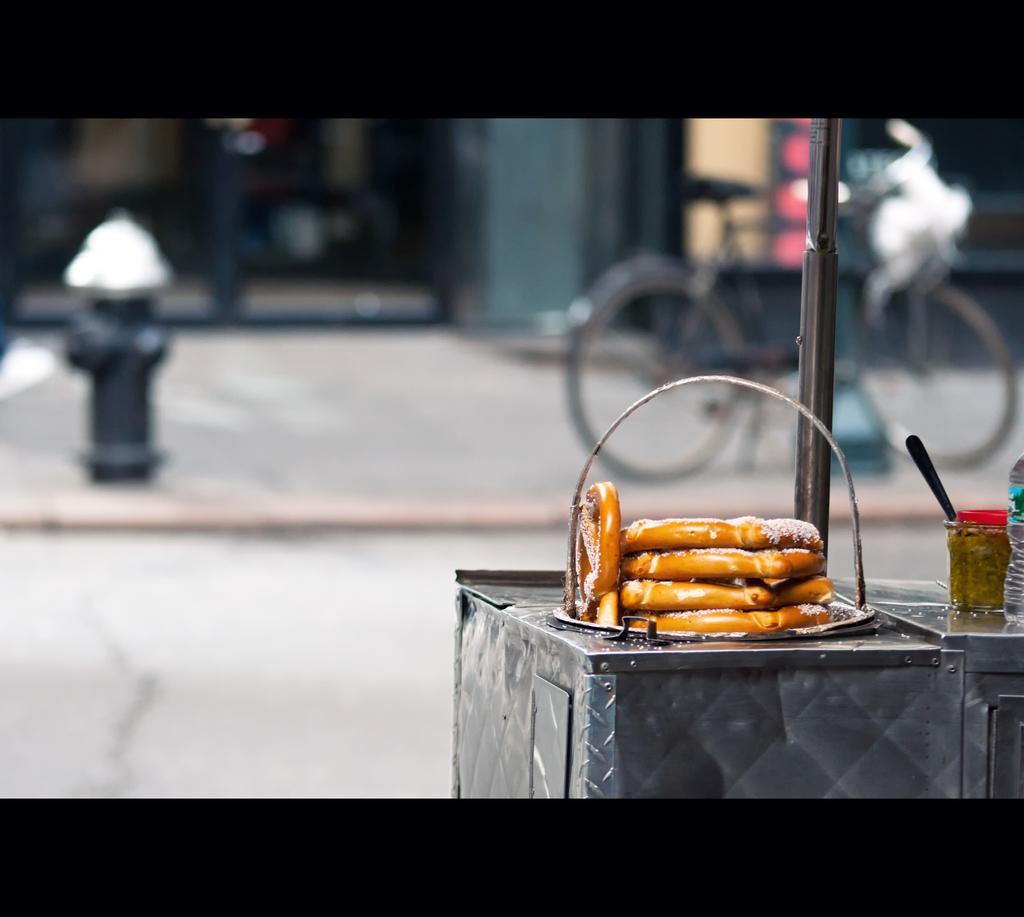Describe this image in one or two sentences. In this image I can see a metal box which is grey in color and on it I can see few food items which are brown in color. I can see a water bottle and few other objects. I can see the blurry background in which I can see the road, a bicycle, a fire hydrant and few other objects. 